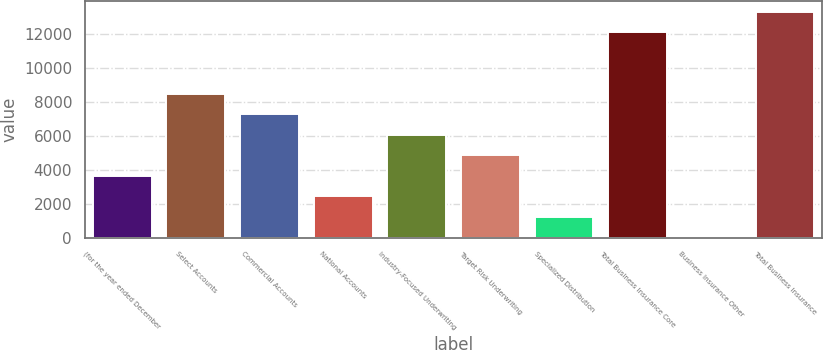Convert chart to OTSL. <chart><loc_0><loc_0><loc_500><loc_500><bar_chart><fcel>(for the year ended December<fcel>Select Accounts<fcel>Commercial Accounts<fcel>National Accounts<fcel>Industry-Focused Underwriting<fcel>Target Risk Underwriting<fcel>Specialized Distribution<fcel>Total Business Insurance Core<fcel>Business Insurance Other<fcel>Total Business Insurance<nl><fcel>3635<fcel>8471<fcel>7262<fcel>2426<fcel>6053<fcel>4844<fcel>1217<fcel>12090<fcel>8<fcel>13299<nl></chart> 